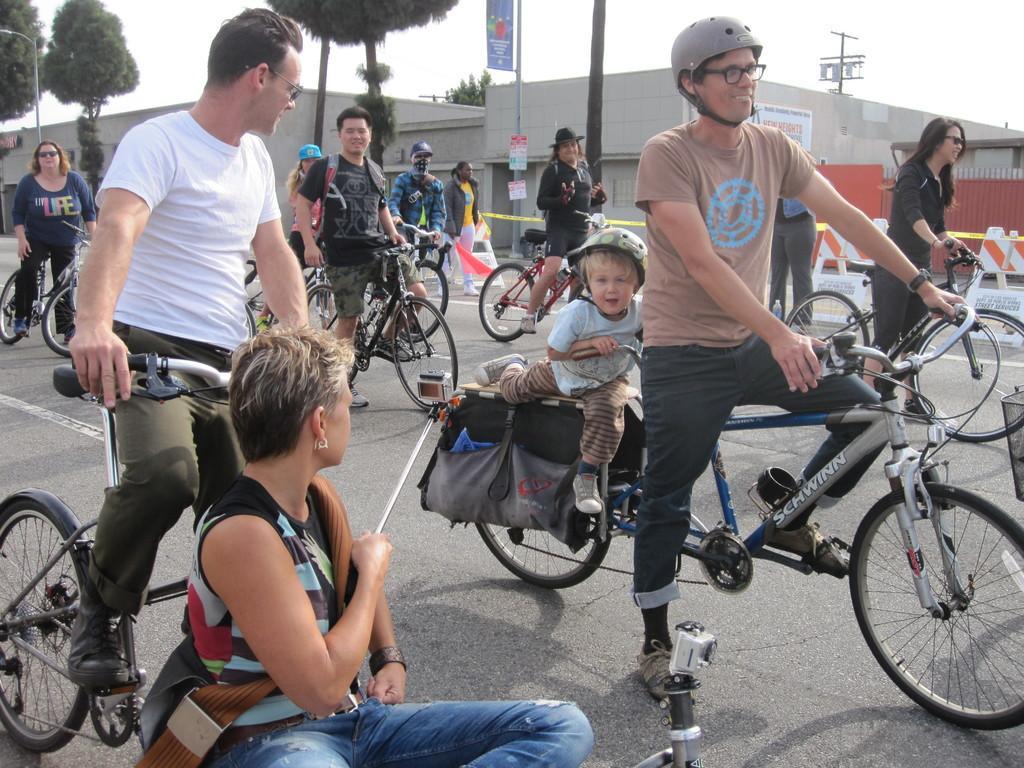Could you give a brief overview of what you see in this image? people are riding bicycles on the road. the person at the front is wearing helmet. behind them there is building and trees. 